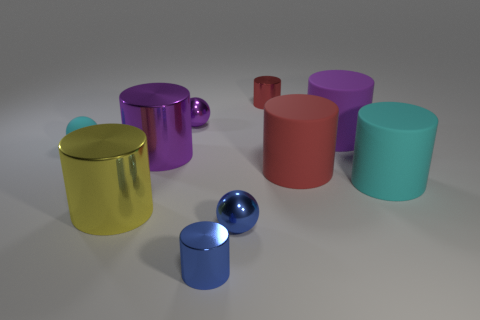Are there any patterns or textures on these objects? No, all the objects present in the image have a smooth, matte finish without any visible patterns or textures. 